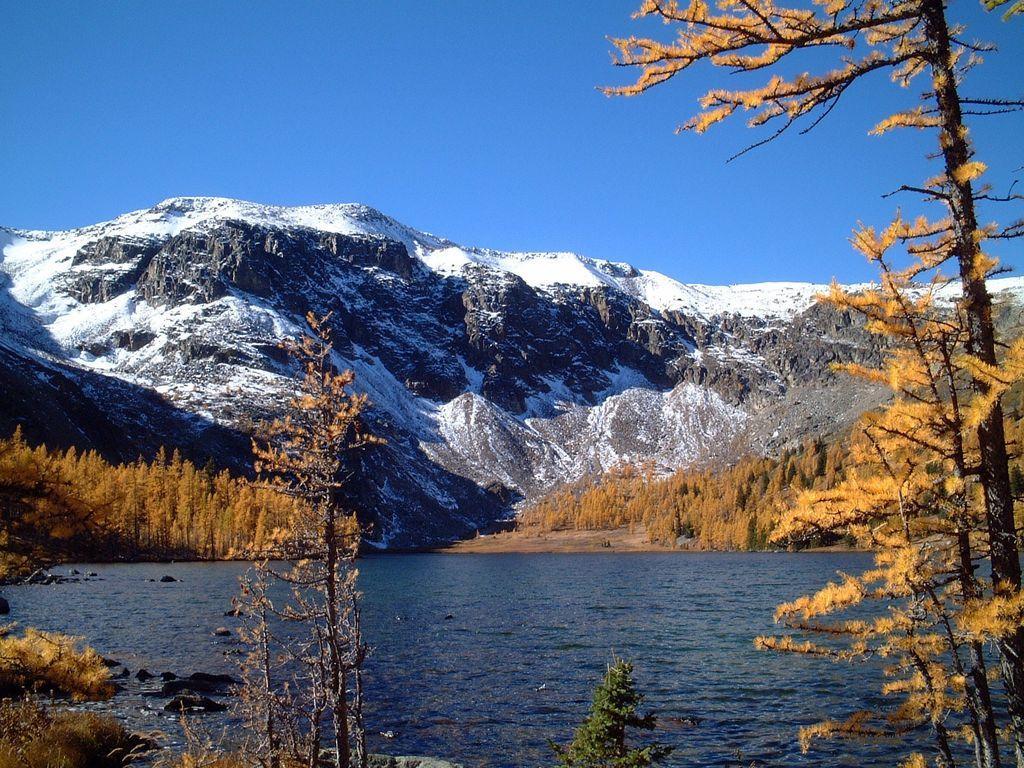Could you give a brief overview of what you see in this image? In this image there is a river, around the river there are trees and plants. In the background there is a mountain and the sky. 